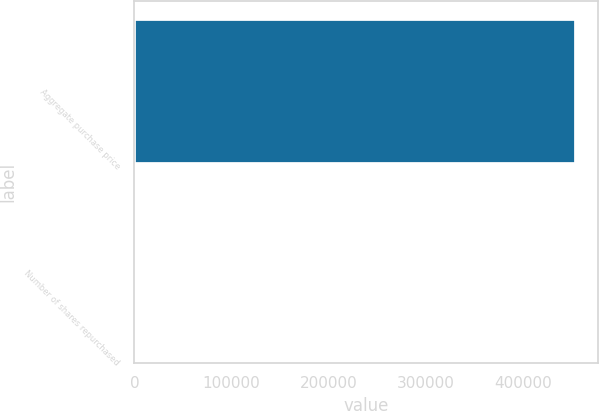<chart> <loc_0><loc_0><loc_500><loc_500><bar_chart><fcel>Aggregate purchase price<fcel>Number of shares repurchased<nl><fcel>455351<fcel>280<nl></chart> 